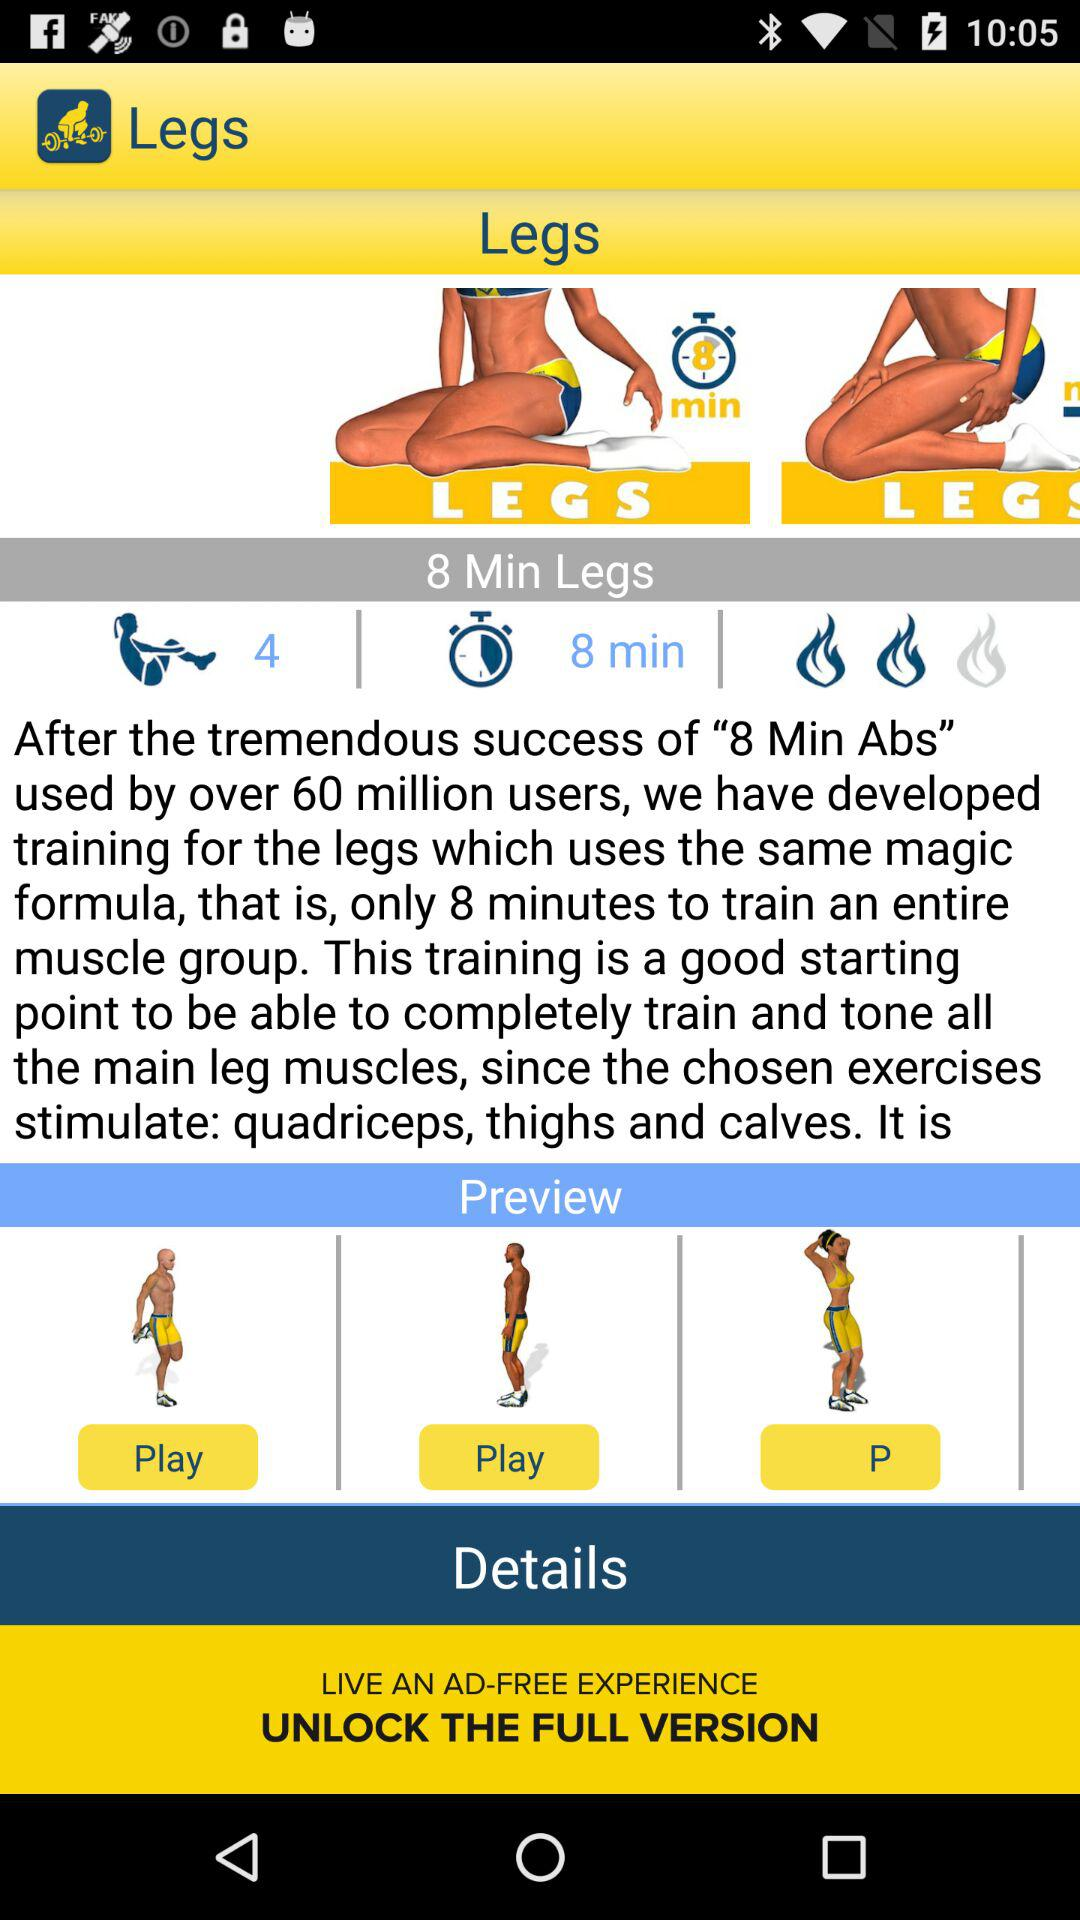What is the duration of the leg exercise? The duration of the leg exercise is 8 minutes. 